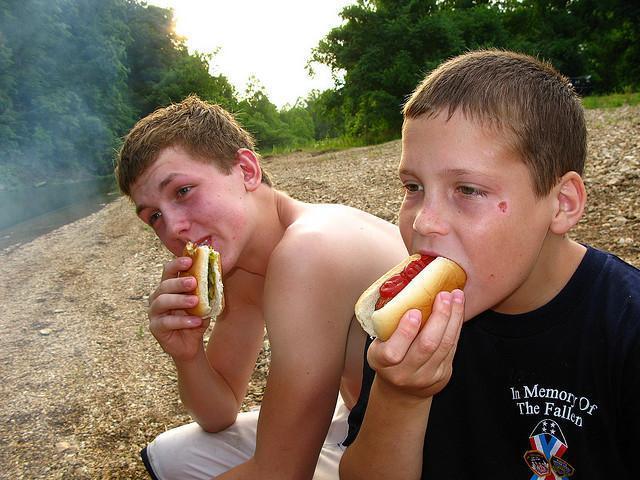How many people are there?
Give a very brief answer. 2. 